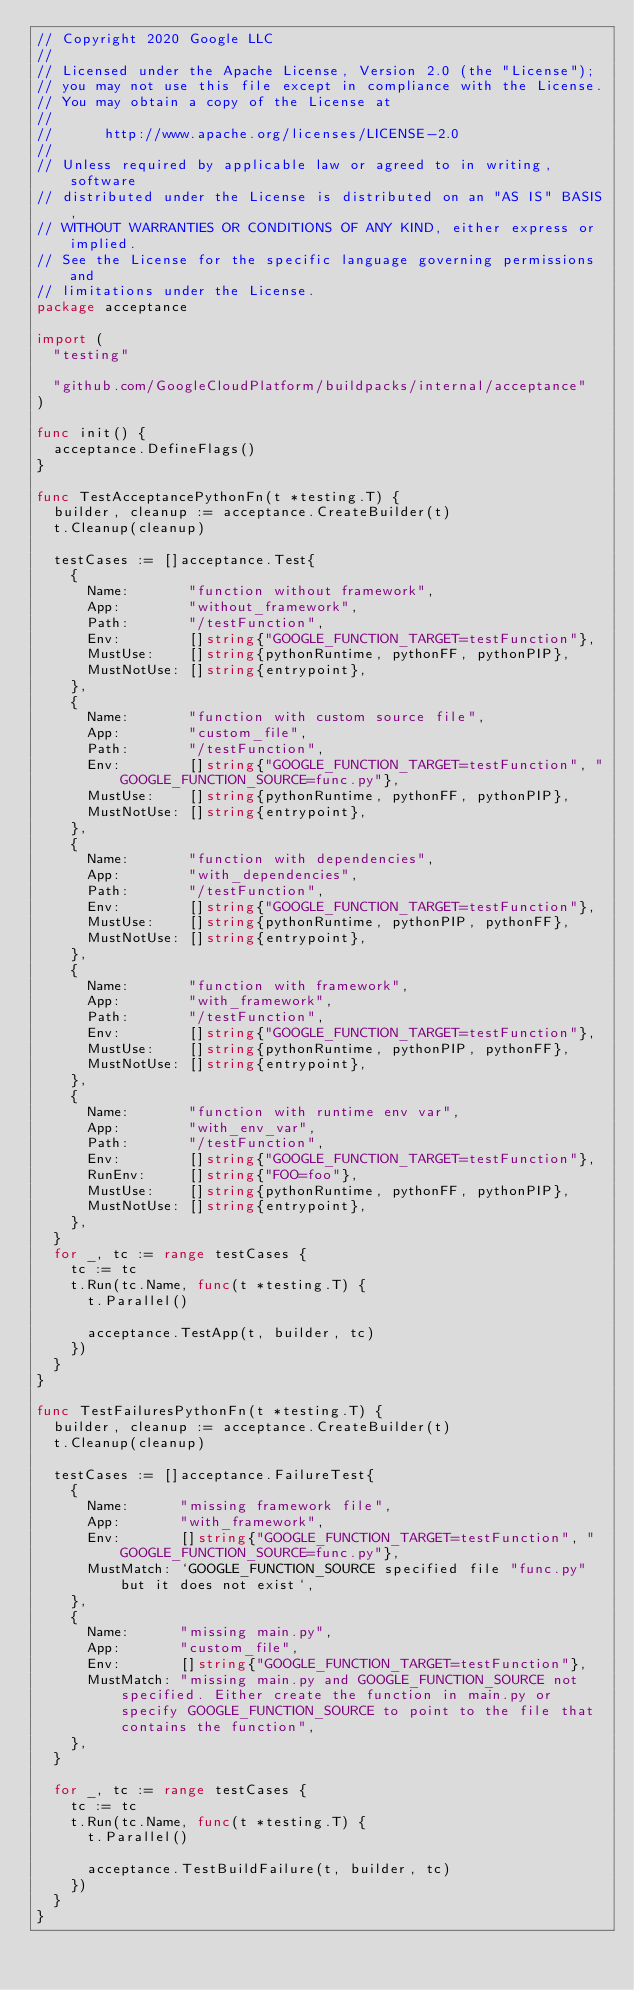Convert code to text. <code><loc_0><loc_0><loc_500><loc_500><_Go_>// Copyright 2020 Google LLC
//
// Licensed under the Apache License, Version 2.0 (the "License");
// you may not use this file except in compliance with the License.
// You may obtain a copy of the License at
//
//      http://www.apache.org/licenses/LICENSE-2.0
//
// Unless required by applicable law or agreed to in writing, software
// distributed under the License is distributed on an "AS IS" BASIS,
// WITHOUT WARRANTIES OR CONDITIONS OF ANY KIND, either express or implied.
// See the License for the specific language governing permissions and
// limitations under the License.
package acceptance

import (
	"testing"

	"github.com/GoogleCloudPlatform/buildpacks/internal/acceptance"
)

func init() {
	acceptance.DefineFlags()
}

func TestAcceptancePythonFn(t *testing.T) {
	builder, cleanup := acceptance.CreateBuilder(t)
	t.Cleanup(cleanup)

	testCases := []acceptance.Test{
		{
			Name:       "function without framework",
			App:        "without_framework",
			Path:       "/testFunction",
			Env:        []string{"GOOGLE_FUNCTION_TARGET=testFunction"},
			MustUse:    []string{pythonRuntime, pythonFF, pythonPIP},
			MustNotUse: []string{entrypoint},
		},
		{
			Name:       "function with custom source file",
			App:        "custom_file",
			Path:       "/testFunction",
			Env:        []string{"GOOGLE_FUNCTION_TARGET=testFunction", "GOOGLE_FUNCTION_SOURCE=func.py"},
			MustUse:    []string{pythonRuntime, pythonFF, pythonPIP},
			MustNotUse: []string{entrypoint},
		},
		{
			Name:       "function with dependencies",
			App:        "with_dependencies",
			Path:       "/testFunction",
			Env:        []string{"GOOGLE_FUNCTION_TARGET=testFunction"},
			MustUse:    []string{pythonRuntime, pythonPIP, pythonFF},
			MustNotUse: []string{entrypoint},
		},
		{
			Name:       "function with framework",
			App:        "with_framework",
			Path:       "/testFunction",
			Env:        []string{"GOOGLE_FUNCTION_TARGET=testFunction"},
			MustUse:    []string{pythonRuntime, pythonPIP, pythonFF},
			MustNotUse: []string{entrypoint},
		},
		{
			Name:       "function with runtime env var",
			App:        "with_env_var",
			Path:       "/testFunction",
			Env:        []string{"GOOGLE_FUNCTION_TARGET=testFunction"},
			RunEnv:     []string{"FOO=foo"},
			MustUse:    []string{pythonRuntime, pythonFF, pythonPIP},
			MustNotUse: []string{entrypoint},
		},
	}
	for _, tc := range testCases {
		tc := tc
		t.Run(tc.Name, func(t *testing.T) {
			t.Parallel()

			acceptance.TestApp(t, builder, tc)
		})
	}
}

func TestFailuresPythonFn(t *testing.T) {
	builder, cleanup := acceptance.CreateBuilder(t)
	t.Cleanup(cleanup)

	testCases := []acceptance.FailureTest{
		{
			Name:      "missing framework file",
			App:       "with_framework",
			Env:       []string{"GOOGLE_FUNCTION_TARGET=testFunction", "GOOGLE_FUNCTION_SOURCE=func.py"},
			MustMatch: `GOOGLE_FUNCTION_SOURCE specified file "func.py" but it does not exist`,
		},
		{
			Name:      "missing main.py",
			App:       "custom_file",
			Env:       []string{"GOOGLE_FUNCTION_TARGET=testFunction"},
			MustMatch: "missing main.py and GOOGLE_FUNCTION_SOURCE not specified. Either create the function in main.py or specify GOOGLE_FUNCTION_SOURCE to point to the file that contains the function",
		},
	}

	for _, tc := range testCases {
		tc := tc
		t.Run(tc.Name, func(t *testing.T) {
			t.Parallel()

			acceptance.TestBuildFailure(t, builder, tc)
		})
	}
}
</code> 